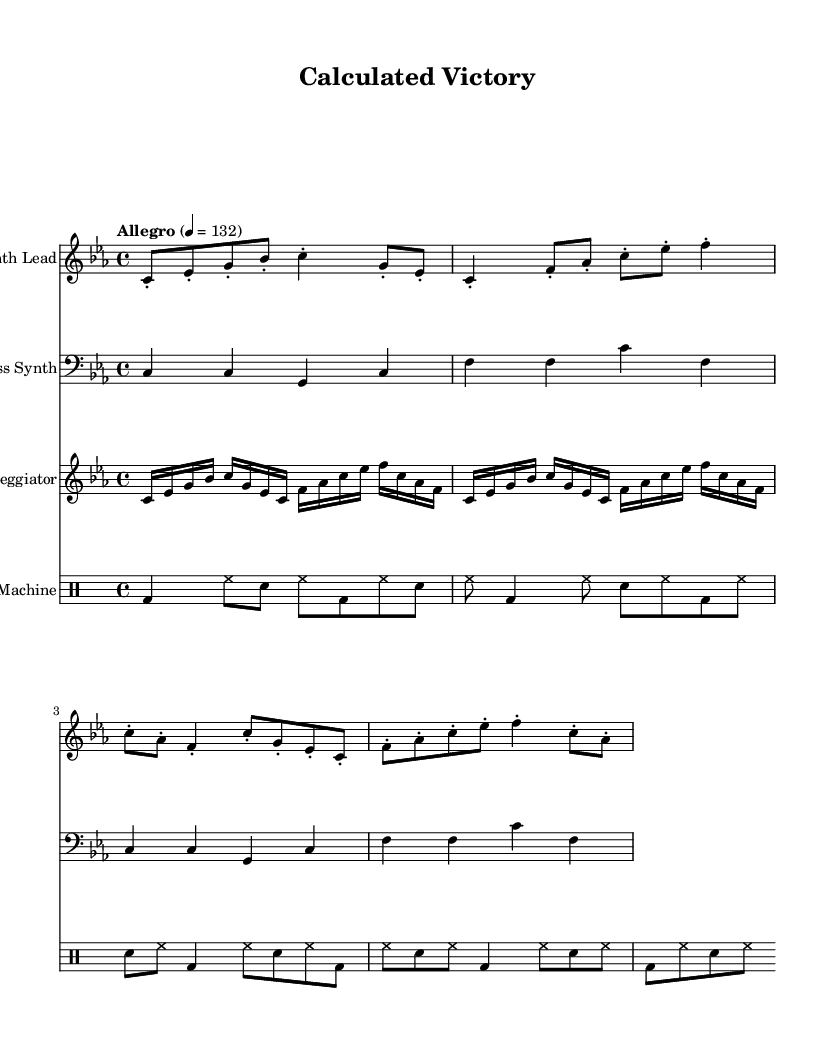What is the key signature of this music? The key signature is C minor, which is indicated by the presence of three flats (B flat, E flat, and A flat).
Answer: C minor What is the time signature of this music? The time signature is 4/4, which means there are four beats in each measure and the quarter note gets one beat.
Answer: 4/4 What is the tempo marking of this piece? The tempo marking indicates that the piece is played at an Allegro pace, specifically at 132 beats per minute.
Answer: Allegro, 132 How many measures does the Synth Lead part contain? By counting the measures in the Synth Lead part, we can see that there are four measures represented in this section.
Answer: 4 measures What is the rhythmic pattern of the drum section? The drum section follows a consistent pattern of kick drum, hi-hat, and snare, repeating every two measures; it establishes the driving beat typical of electronic music.
Answer: Repeating kick-snare-hi-hat pattern What type of synthesizer is used for the lead instrument? The lead instrument is described as a "lead 2 (sawtooth)" synthesizer, which is a common sound in electronic music for its bright and cutting tone.
Answer: lead 2 (sawtooth) What is the overall structure of the piece based on the parts? The overall structure consists of a Synth Lead, Bass Synth, Arpeggiator, and Drum Machine, coming together to create a layered electronic sound.
Answer: Synth Lead, Bass Synth, Arpeggiator, Drum Machine 